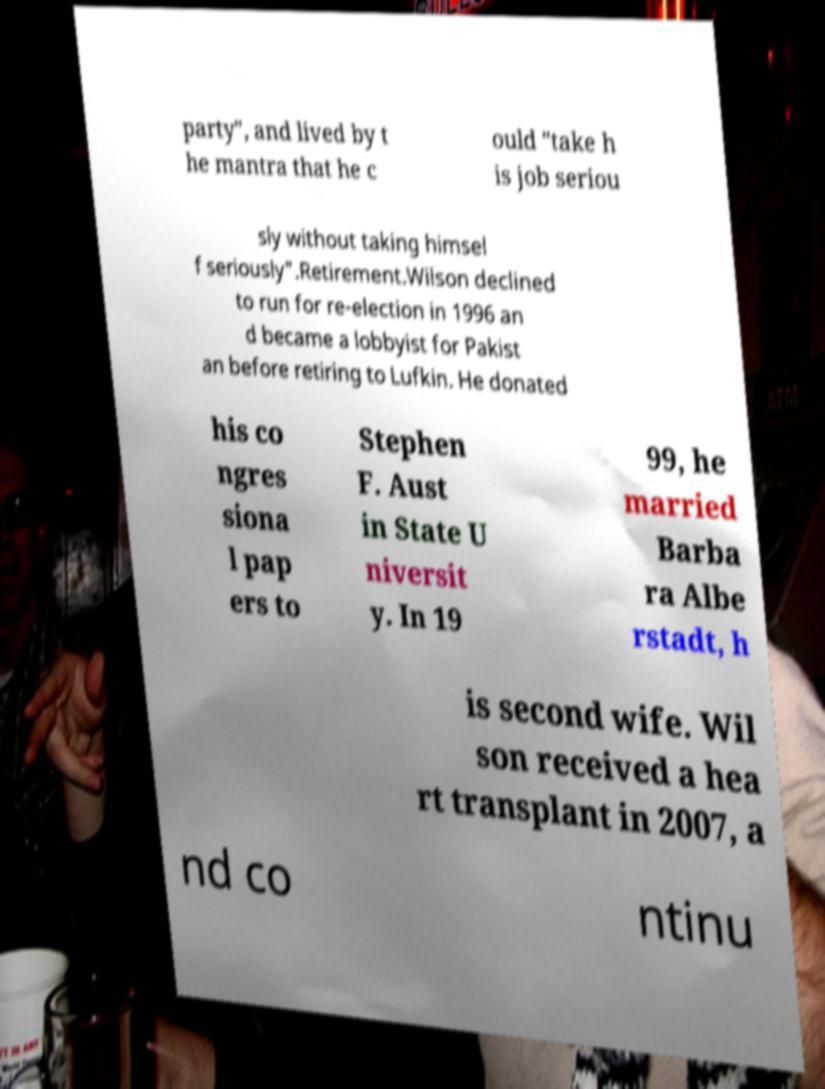Can you read and provide the text displayed in the image?This photo seems to have some interesting text. Can you extract and type it out for me? party", and lived by t he mantra that he c ould "take h is job seriou sly without taking himsel f seriously".Retirement.Wilson declined to run for re-election in 1996 an d became a lobbyist for Pakist an before retiring to Lufkin. He donated his co ngres siona l pap ers to Stephen F. Aust in State U niversit y. In 19 99, he married Barba ra Albe rstadt, h is second wife. Wil son received a hea rt transplant in 2007, a nd co ntinu 